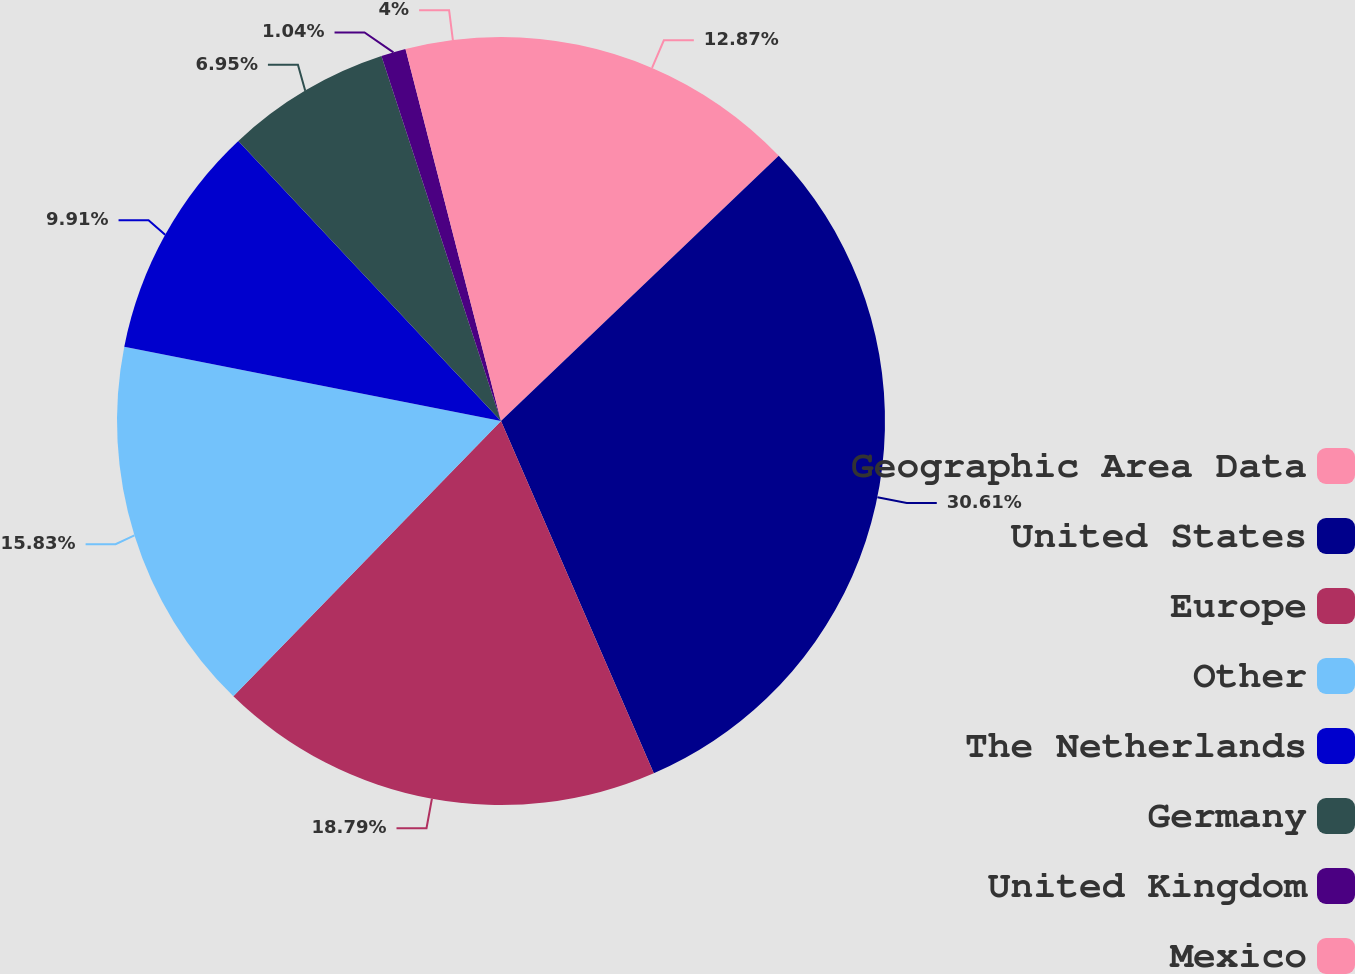<chart> <loc_0><loc_0><loc_500><loc_500><pie_chart><fcel>Geographic Area Data<fcel>United States<fcel>Europe<fcel>Other<fcel>The Netherlands<fcel>Germany<fcel>United Kingdom<fcel>Mexico<nl><fcel>12.87%<fcel>30.62%<fcel>18.79%<fcel>15.83%<fcel>9.91%<fcel>6.95%<fcel>1.04%<fcel>4.0%<nl></chart> 